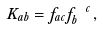Convert formula to latex. <formula><loc_0><loc_0><loc_500><loc_500>K _ { a b } = f _ { a c } f ^ { \ c } _ { b } \, ,</formula> 